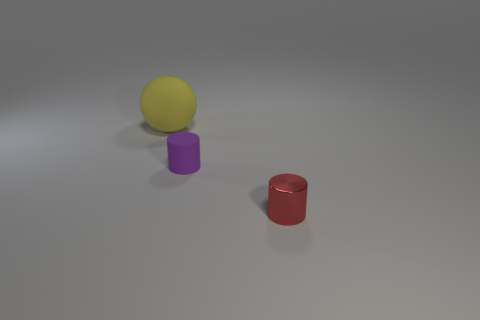Add 1 purple rubber things. How many objects exist? 4 Subtract all purple cylinders. How many cylinders are left? 1 Subtract all balls. How many objects are left? 2 Subtract 1 cylinders. How many cylinders are left? 1 Subtract all cyan balls. How many red cylinders are left? 1 Add 1 tiny purple objects. How many tiny purple objects are left? 2 Add 2 cyan metallic spheres. How many cyan metallic spheres exist? 2 Subtract 1 red cylinders. How many objects are left? 2 Subtract all brown cylinders. Subtract all red cubes. How many cylinders are left? 2 Subtract all tiny cylinders. Subtract all gray things. How many objects are left? 1 